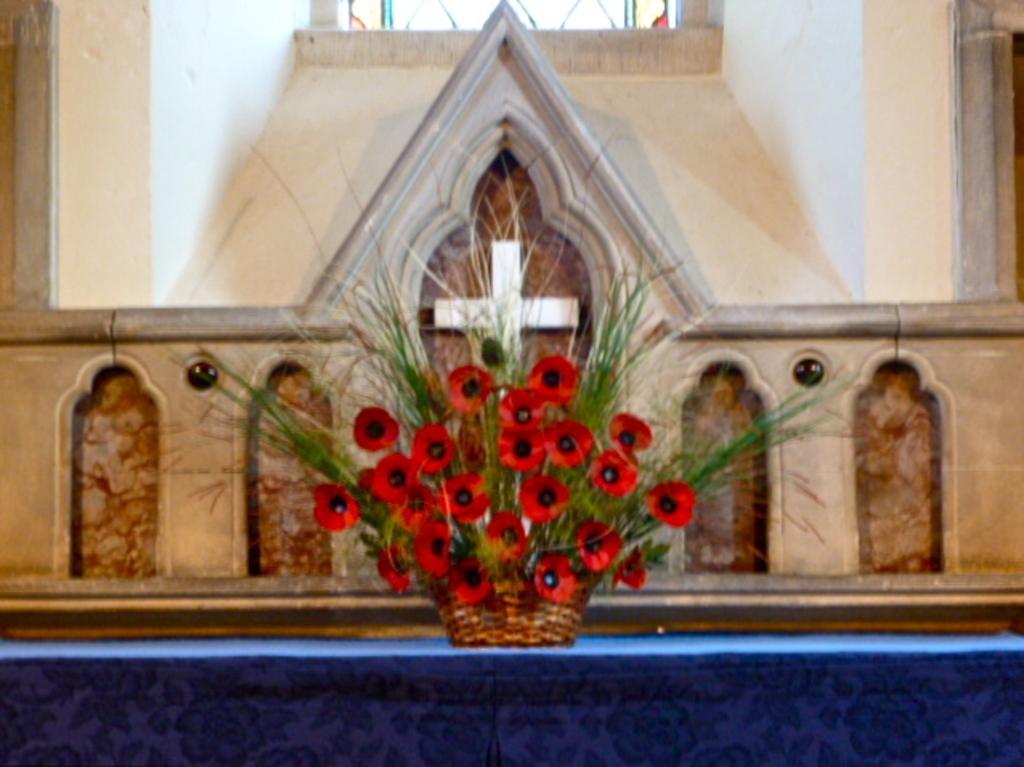In one or two sentences, can you explain what this image depicts? In this image there is a flower pot on the table, behind the flower pot there is a wall with a cross on it. 